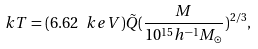<formula> <loc_0><loc_0><loc_500><loc_500>k T = ( 6 . 6 2 \, \ k e V ) \tilde { Q } ( \frac { M } { 1 0 ^ { 1 5 } h ^ { - 1 } M _ { \odot } } ) ^ { 2 / 3 } ,</formula> 